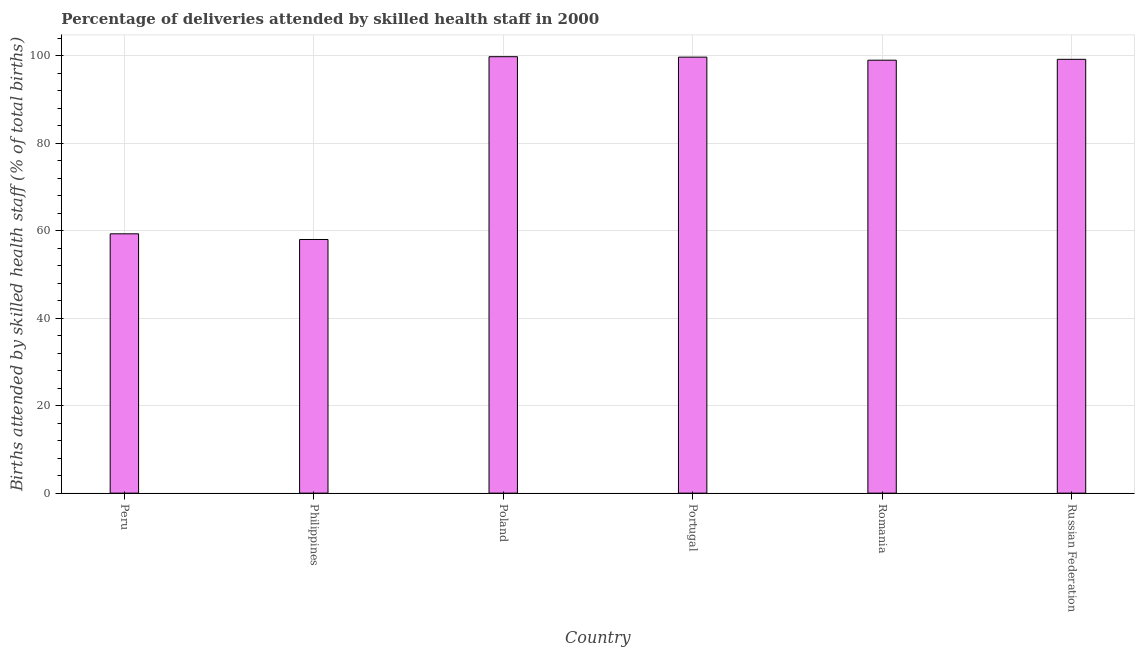Does the graph contain grids?
Your answer should be compact. Yes. What is the title of the graph?
Keep it short and to the point. Percentage of deliveries attended by skilled health staff in 2000. What is the label or title of the Y-axis?
Offer a very short reply. Births attended by skilled health staff (% of total births). What is the number of births attended by skilled health staff in Russian Federation?
Provide a short and direct response. 99.2. Across all countries, what is the maximum number of births attended by skilled health staff?
Give a very brief answer. 99.8. In which country was the number of births attended by skilled health staff maximum?
Ensure brevity in your answer.  Poland. In which country was the number of births attended by skilled health staff minimum?
Ensure brevity in your answer.  Philippines. What is the sum of the number of births attended by skilled health staff?
Your response must be concise. 515. What is the difference between the number of births attended by skilled health staff in Poland and Russian Federation?
Offer a very short reply. 0.6. What is the average number of births attended by skilled health staff per country?
Make the answer very short. 85.83. What is the median number of births attended by skilled health staff?
Make the answer very short. 99.1. What is the difference between the highest and the lowest number of births attended by skilled health staff?
Offer a very short reply. 41.8. In how many countries, is the number of births attended by skilled health staff greater than the average number of births attended by skilled health staff taken over all countries?
Keep it short and to the point. 4. How many bars are there?
Make the answer very short. 6. Are all the bars in the graph horizontal?
Make the answer very short. No. What is the Births attended by skilled health staff (% of total births) of Peru?
Give a very brief answer. 59.3. What is the Births attended by skilled health staff (% of total births) in Poland?
Ensure brevity in your answer.  99.8. What is the Births attended by skilled health staff (% of total births) of Portugal?
Your response must be concise. 99.7. What is the Births attended by skilled health staff (% of total births) in Russian Federation?
Offer a terse response. 99.2. What is the difference between the Births attended by skilled health staff (% of total births) in Peru and Poland?
Provide a short and direct response. -40.5. What is the difference between the Births attended by skilled health staff (% of total births) in Peru and Portugal?
Keep it short and to the point. -40.4. What is the difference between the Births attended by skilled health staff (% of total births) in Peru and Romania?
Offer a very short reply. -39.7. What is the difference between the Births attended by skilled health staff (% of total births) in Peru and Russian Federation?
Give a very brief answer. -39.9. What is the difference between the Births attended by skilled health staff (% of total births) in Philippines and Poland?
Keep it short and to the point. -41.8. What is the difference between the Births attended by skilled health staff (% of total births) in Philippines and Portugal?
Provide a succinct answer. -41.7. What is the difference between the Births attended by skilled health staff (% of total births) in Philippines and Romania?
Offer a very short reply. -41. What is the difference between the Births attended by skilled health staff (% of total births) in Philippines and Russian Federation?
Offer a terse response. -41.2. What is the difference between the Births attended by skilled health staff (% of total births) in Poland and Portugal?
Offer a terse response. 0.1. What is the ratio of the Births attended by skilled health staff (% of total births) in Peru to that in Poland?
Keep it short and to the point. 0.59. What is the ratio of the Births attended by skilled health staff (% of total births) in Peru to that in Portugal?
Provide a succinct answer. 0.59. What is the ratio of the Births attended by skilled health staff (% of total births) in Peru to that in Romania?
Your answer should be compact. 0.6. What is the ratio of the Births attended by skilled health staff (% of total births) in Peru to that in Russian Federation?
Make the answer very short. 0.6. What is the ratio of the Births attended by skilled health staff (% of total births) in Philippines to that in Poland?
Offer a very short reply. 0.58. What is the ratio of the Births attended by skilled health staff (% of total births) in Philippines to that in Portugal?
Ensure brevity in your answer.  0.58. What is the ratio of the Births attended by skilled health staff (% of total births) in Philippines to that in Romania?
Your answer should be compact. 0.59. What is the ratio of the Births attended by skilled health staff (% of total births) in Philippines to that in Russian Federation?
Your answer should be compact. 0.58. What is the ratio of the Births attended by skilled health staff (% of total births) in Poland to that in Portugal?
Ensure brevity in your answer.  1. What is the ratio of the Births attended by skilled health staff (% of total births) in Poland to that in Romania?
Make the answer very short. 1.01. What is the ratio of the Births attended by skilled health staff (% of total births) in Romania to that in Russian Federation?
Your response must be concise. 1. 